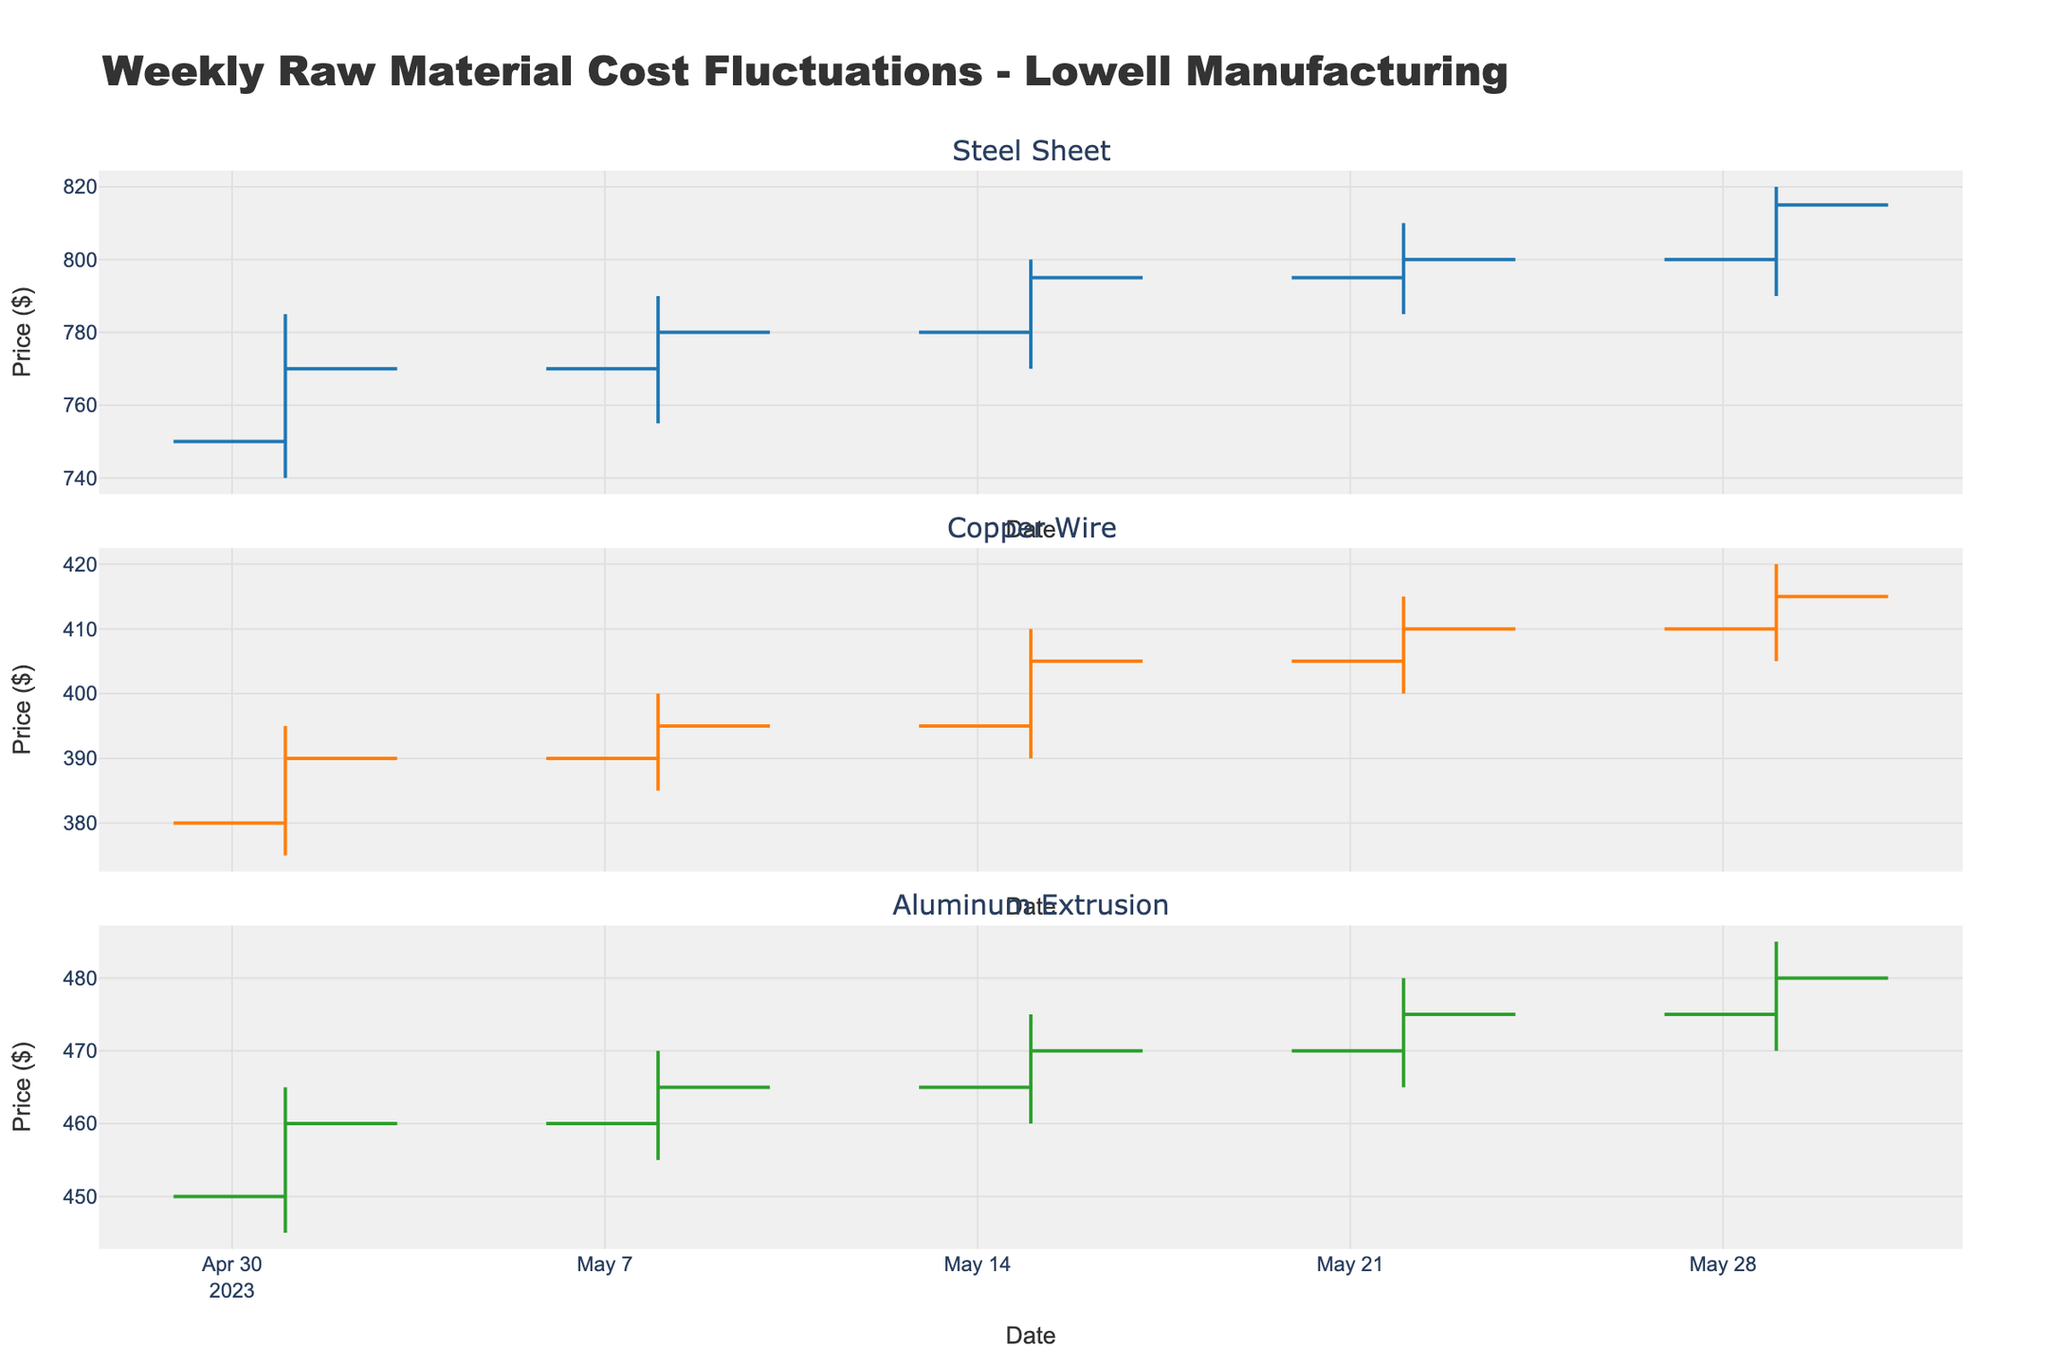What is the title of the figure? The title of the figure is located at the top of the plot; it is 'Weekly Raw Material Cost Fluctuations - Lowell Manufacturing'.
Answer: Weekly Raw Material Cost Fluctuations - Lowell Manufacturing Which component had the highest closing price in May 2023? To find the component with the highest closing price, look at the closing prices for all the components over the weeks of May 2023. The highest closing price can be observed at the end of May 2023 for Aluminum Extrusion with a closing price of $480.
Answer: Aluminum Extrusion What is the average high price for Steel Sheet in May 2023? To calculate the average high price for Steel Sheet, sum up all the high prices for each week and divide by the number of weeks. The high prices are 785, 790, 800, 810, and 820. The sum is 785 + 790 + 800 + 810 + 820 = 4005. There are 5 weeks in May, so the average is 4005 / 5 = 801.
Answer: 801 Did any component witness a decrease in their closing price from one week to the next? By examining the closing prices week-by-week for each component, it is visible that none of the components experienced a decrease in their closing prices from one week to the next; all saw either increases or remained the same.
Answer: No Which week had the highest volatility for Copper Wire? Volatility can be considered as the difference between the high and low prices for each week. Calculate the difference for each week of Copper Wire and find the week with the maximum difference. The differences are as follows: Week 1: 395-375=20, Week 2: 400-385=15, Week 3: 410-390=20, Week 4: 415-400=15, Week 5: 420-405=15. The highest volatility is in Week 1 and Week 3 with a difference of 20.
Answer: Week 1 and Week 3 Comparing the opening and closing prices of Aluminum Extrusion, did the value always increase by the end of the week? By comparing the opening and closing prices for Aluminum Extrusion each week, it can be noted that the closing price is always higher than the opening price. Therefore, the value increased each week.
Answer: Yes What was the overall trend in the prices of Steel Sheet over the weeks of May 2023? By observing the opening and closing prices of Steel Sheet across the weeks, there is a general upward trend: starting from an opening price of $750 and closing at $815.
Answer: Upward trend During which week did Steel Sheet have its lowest opening price? The lowest opening price for Steel Sheet can be identified from the data provided for each week. The lowest opening price was $750 in the week of 2023-05-01.
Answer: 2023-05-01 What is the difference between the highest and lowest closing prices of Copper Wire in May 2023? To find this difference, identify the highest and lowest closing prices for Copper Wire in the month of May 2023. The highest closing price is $415 and the lowest is $390. The difference is 415 - 390 = 25.
Answer: 25 